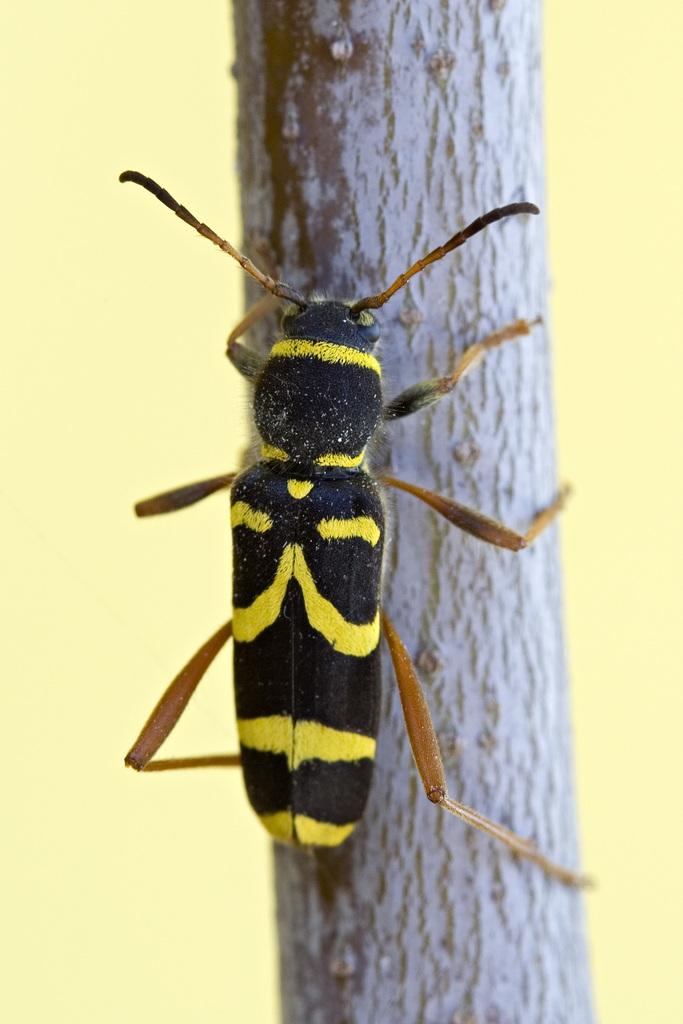What is on the wall in the image? There is an insect on the wall in the image. What can be seen in the background of the image? There is a plain wall visible in the background of the image. What type of twist can be seen in the image? There is no twist present in the image. Can you see a kettle in the image? There is no kettle present in the image. 